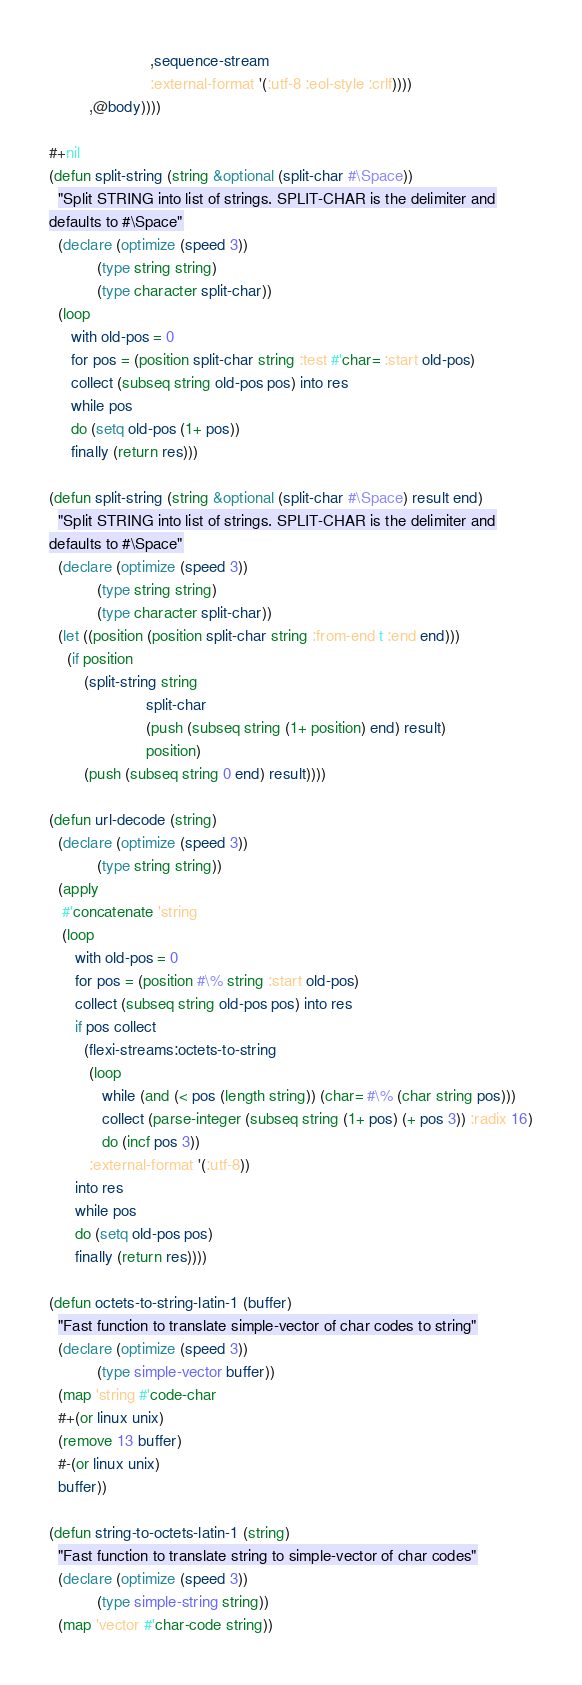Convert code to text. <code><loc_0><loc_0><loc_500><loc_500><_Lisp_>                       ,sequence-stream
                       :external-format '(:utf-8 :eol-style :crlf))))
         ,@body))))

#+nil
(defun split-string (string &optional (split-char #\Space))
  "Split STRING into list of strings. SPLIT-CHAR is the delimiter and
defaults to #\Space"
  (declare (optimize (speed 3))
           (type string string)
           (type character split-char))
  (loop
     with old-pos = 0
     for pos = (position split-char string :test #'char= :start old-pos)
     collect (subseq string old-pos pos) into res
     while pos
     do (setq old-pos (1+ pos))
     finally (return res)))

(defun split-string (string &optional (split-char #\Space) result end)
  "Split STRING into list of strings. SPLIT-CHAR is the delimiter and
defaults to #\Space"
  (declare (optimize (speed 3))
           (type string string)
           (type character split-char))
  (let ((position (position split-char string :from-end t :end end)))
    (if position
        (split-string string
                      split-char
                      (push (subseq string (1+ position) end) result)
                      position)
        (push (subseq string 0 end) result))))

(defun url-decode (string)
  (declare (optimize (speed 3))
           (type string string))
  (apply
   #'concatenate 'string
   (loop
      with old-pos = 0
      for pos = (position #\% string :start old-pos)
      collect (subseq string old-pos pos) into res
      if pos collect
        (flexi-streams:octets-to-string
         (loop
            while (and (< pos (length string)) (char= #\% (char string pos)))
            collect (parse-integer (subseq string (1+ pos) (+ pos 3)) :radix 16)
            do (incf pos 3))
         :external-format '(:utf-8))
      into res
      while pos
      do (setq old-pos pos)
      finally (return res))))

(defun octets-to-string-latin-1 (buffer)
  "Fast function to translate simple-vector of char codes to string"
  (declare (optimize (speed 3))
           (type simple-vector buffer))
  (map 'string #'code-char
  #+(or linux unix)
  (remove 13 buffer)
  #-(or linux unix)
  buffer))

(defun string-to-octets-latin-1 (string)
  "Fast function to translate string to simple-vector of char codes"
  (declare (optimize (speed 3))
           (type simple-string string))
  (map 'vector #'char-code string))
</code> 